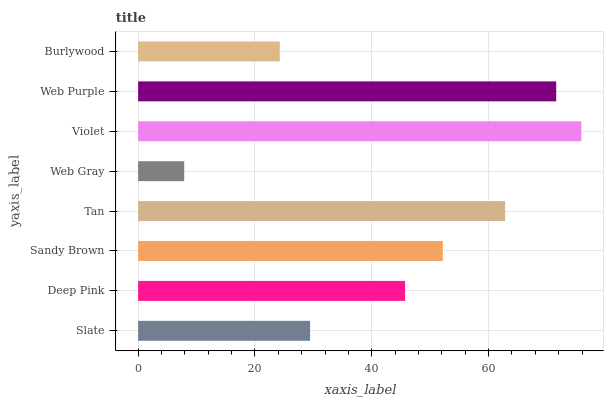Is Web Gray the minimum?
Answer yes or no. Yes. Is Violet the maximum?
Answer yes or no. Yes. Is Deep Pink the minimum?
Answer yes or no. No. Is Deep Pink the maximum?
Answer yes or no. No. Is Deep Pink greater than Slate?
Answer yes or no. Yes. Is Slate less than Deep Pink?
Answer yes or no. Yes. Is Slate greater than Deep Pink?
Answer yes or no. No. Is Deep Pink less than Slate?
Answer yes or no. No. Is Sandy Brown the high median?
Answer yes or no. Yes. Is Deep Pink the low median?
Answer yes or no. Yes. Is Tan the high median?
Answer yes or no. No. Is Tan the low median?
Answer yes or no. No. 